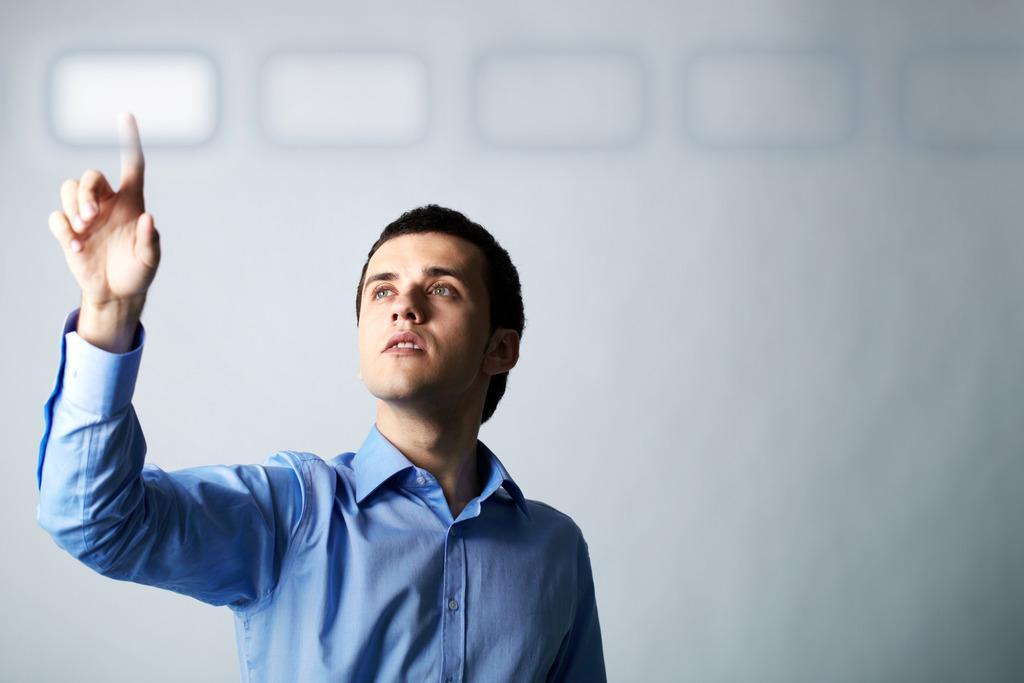How would you summarize this image in a sentence or two? In this image I can see a person standing and wearing blue color dress. Background is in white color. 